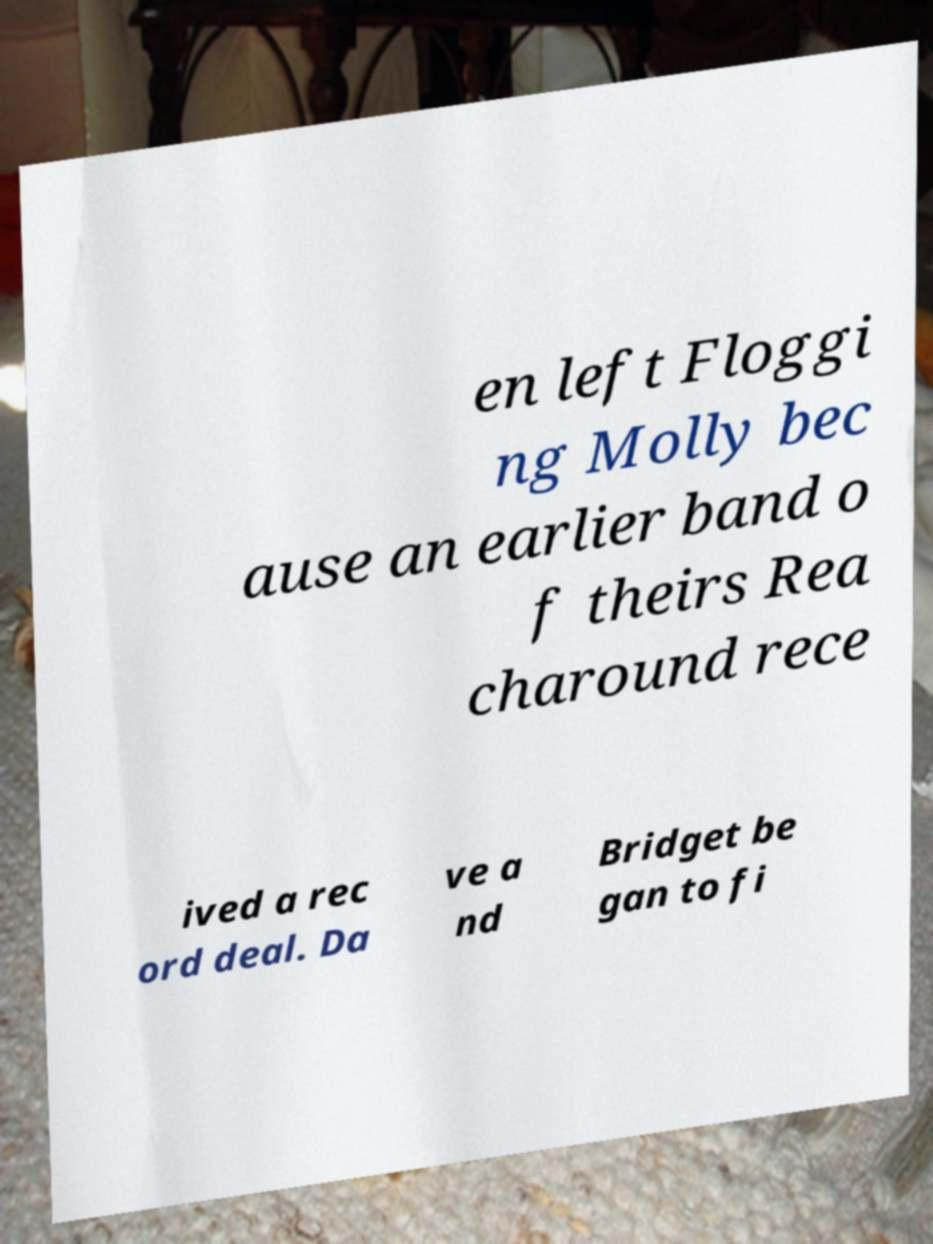Could you assist in decoding the text presented in this image and type it out clearly? en left Floggi ng Molly bec ause an earlier band o f theirs Rea charound rece ived a rec ord deal. Da ve a nd Bridget be gan to fi 